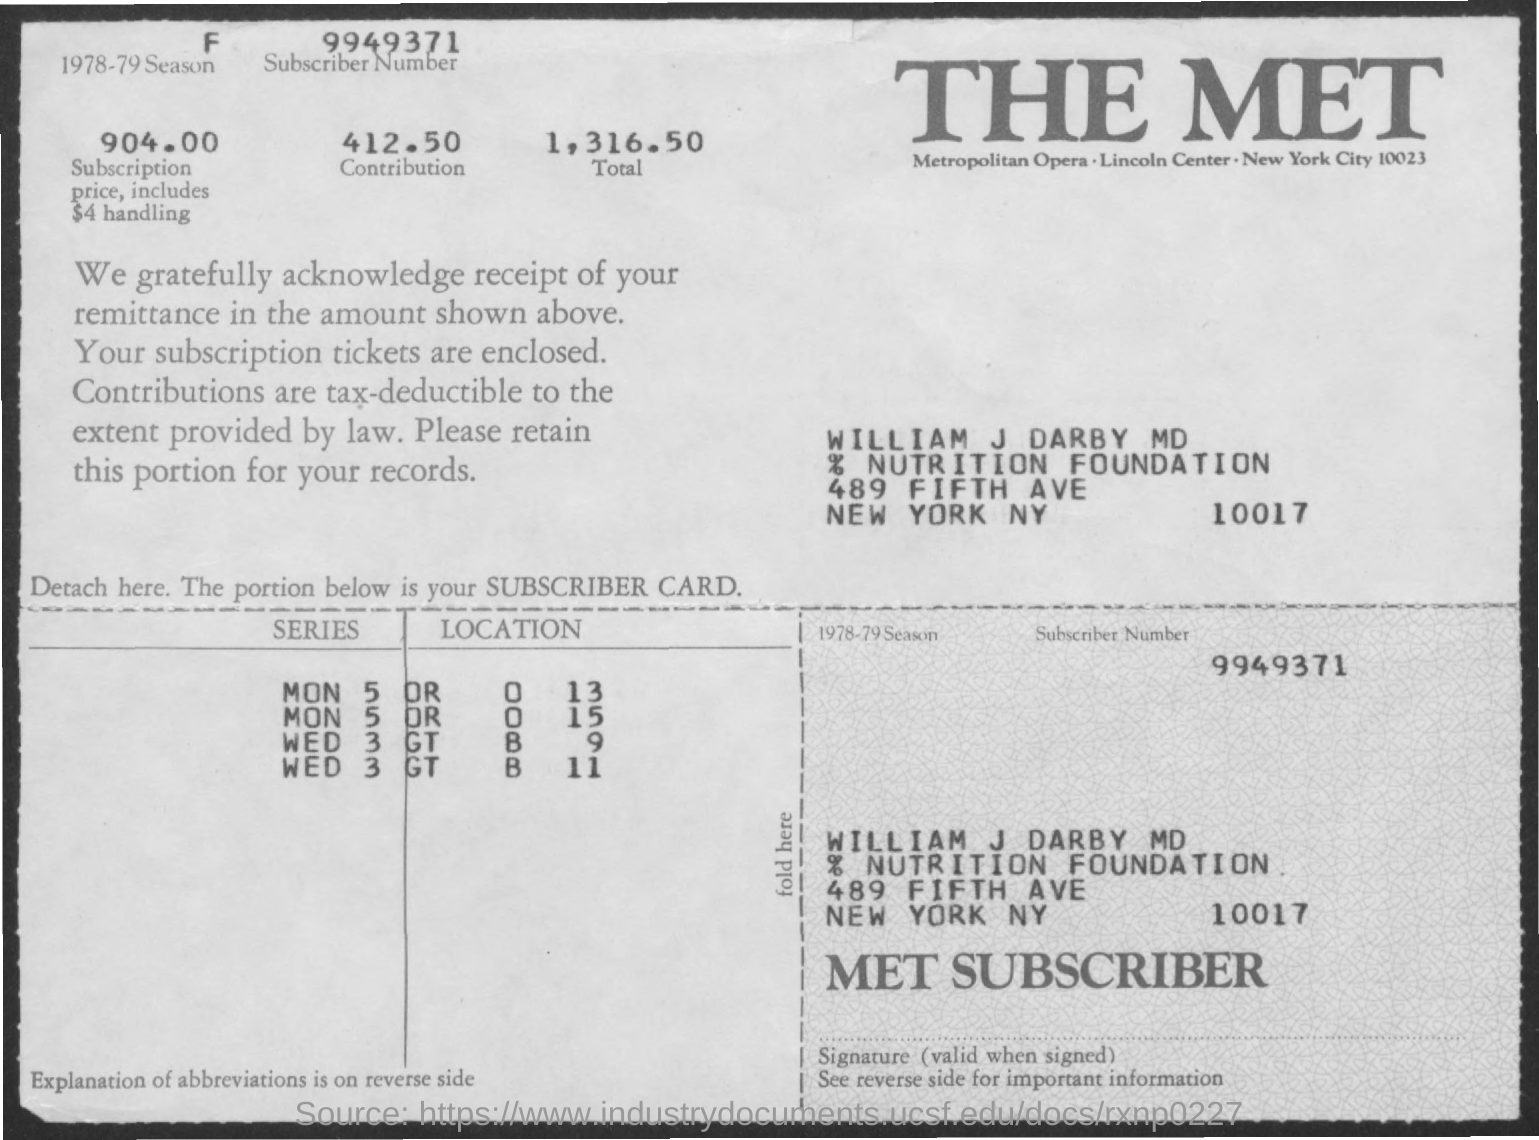What is the Subscriber Number?
Provide a succinct answer. 9949371. What is the Subscription price?
Ensure brevity in your answer.  904.00. What is the contribution?
Keep it short and to the point. 412.50. What is the Total?
Keep it short and to the point. 1,316.50. Who is the MET subscriber?
Make the answer very short. William j darby md. What is the 1978-79 season?
Offer a very short reply. F. 